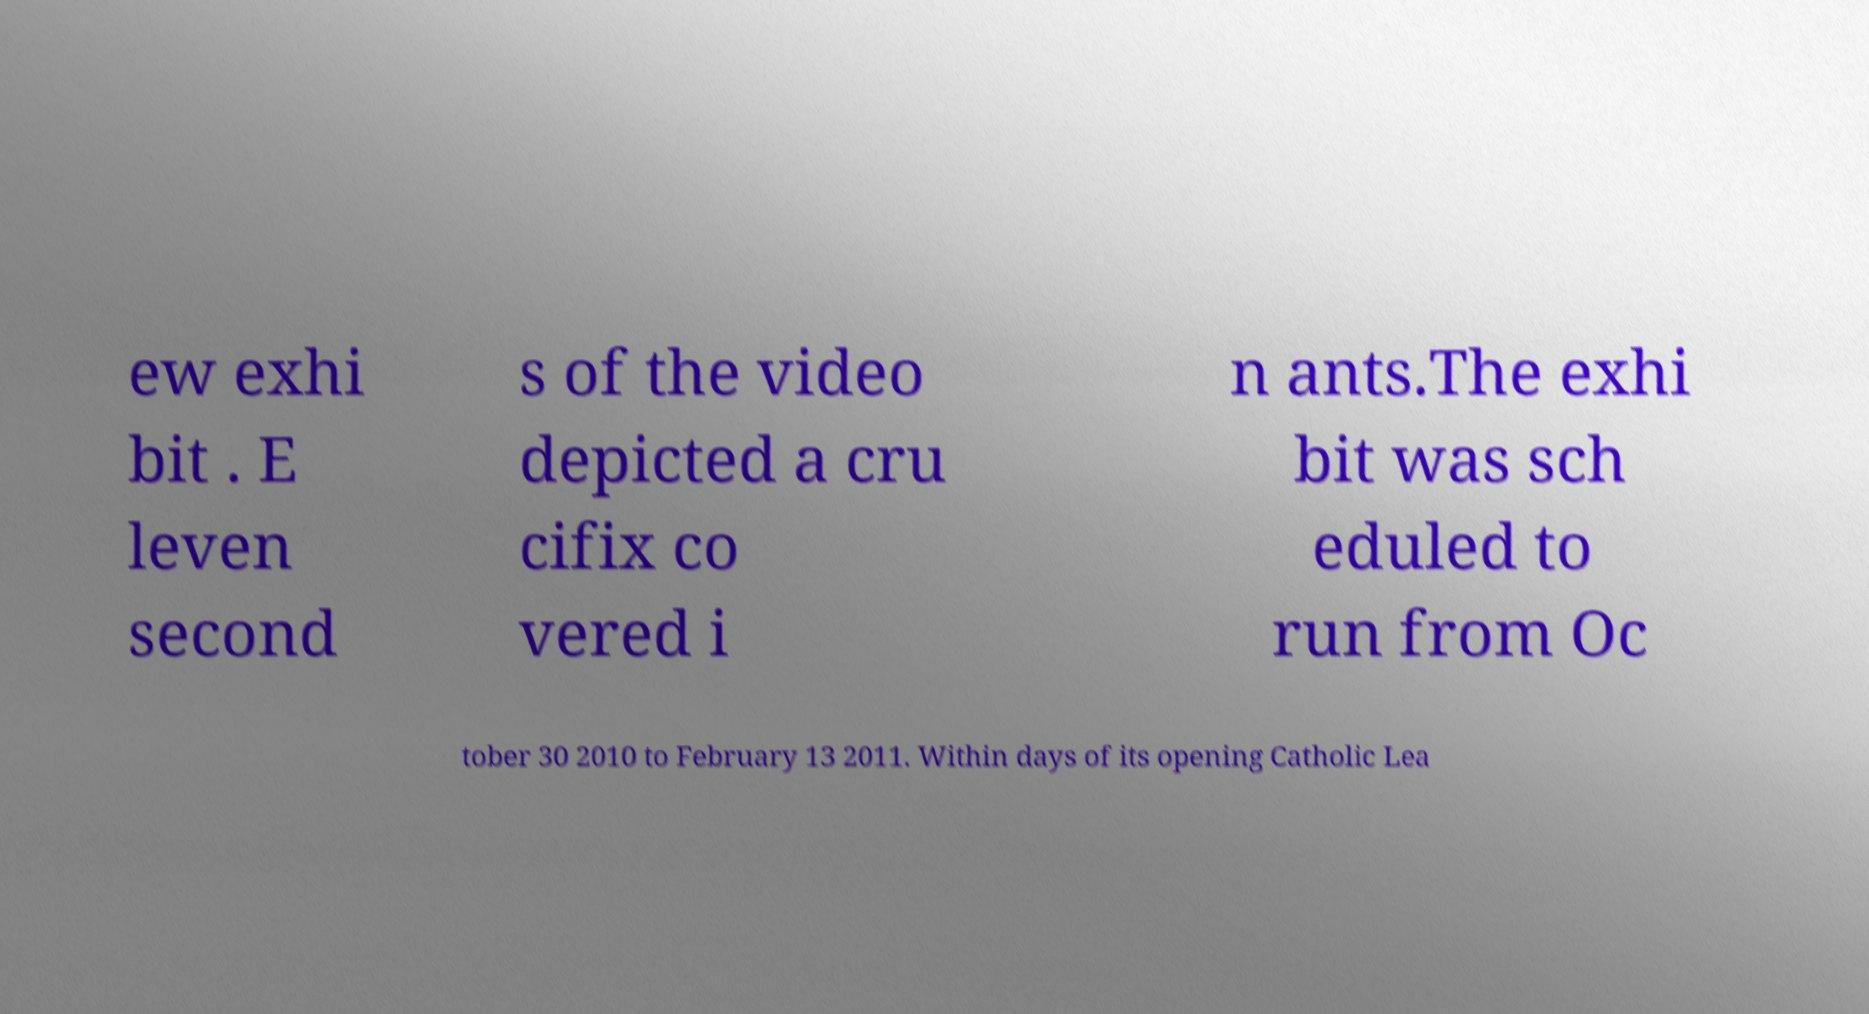Could you extract and type out the text from this image? ew exhi bit . E leven second s of the video depicted a cru cifix co vered i n ants.The exhi bit was sch eduled to run from Oc tober 30 2010 to February 13 2011. Within days of its opening Catholic Lea 